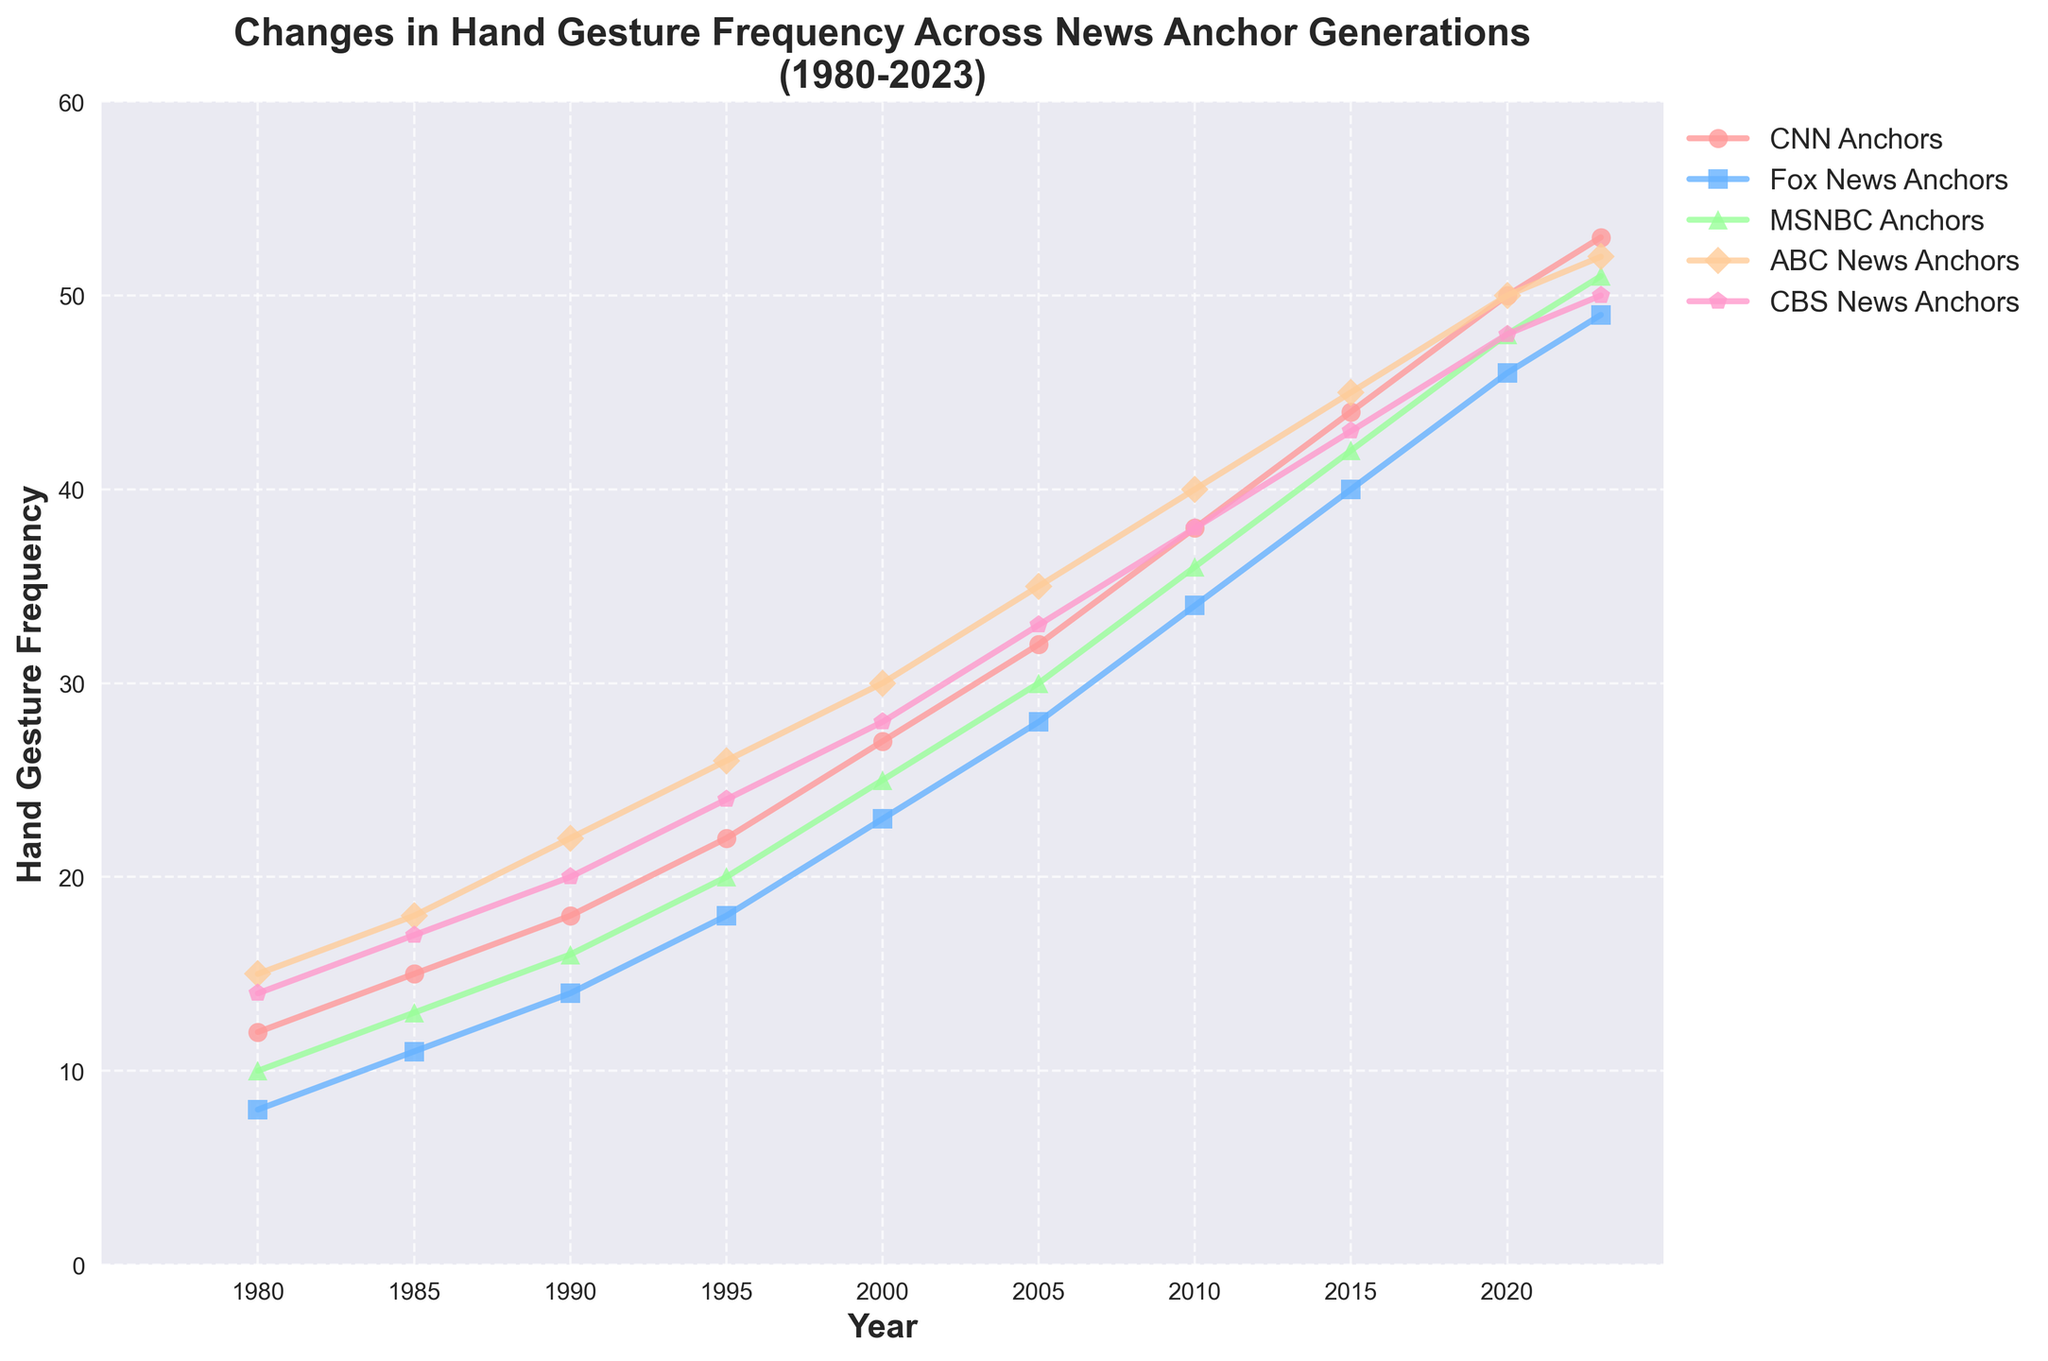What is the frequency of hand gestures for ABC News Anchors in 1995? Refer to the chart and locate the value corresponding to 1995 under ABC News Anchors which is shown as 26 hand gestures.
Answer: 26 Between which years did MSNBC Anchors show the greatest increase in hand gesture frequency? Compare the increase in frequency across intervals and find the largest increase for MSNBC Anchors. The most significant increase occurred between 2010 (36) and 2015 (42), a change of 6.
Answer: 2010 to 2015 Which news network showed the least hand gesture frequency in 1980? Compare the hand gesture frequencies for all networks in 1980. Fox News Anchors had the least frequency with 8 hand gestures.
Answer: Fox News Anchors How does the frequency of hand gestures for CBS News Anchors in 2020 compare to CNN Anchors in 1990? Refer to the values for CBS News Anchors in 2020 (48) and CNN Anchors in 1990 (18). Compare these values directly.
Answer: Higher By what amount did the frequency of hand gestures for CNN Anchors increase from 1980 to 2023? Subtract the value in 1980 (12) from the value in 2023 (53) for CNN Anchors to get the increase: 53 - 12 = 41.
Answer: 41 Which two networks had the same hand gesture frequency in 2023? Look at the values for 2023 and identify which two networks match in hand gesture frequency. Both ABC News Anchors and CBS News Anchors have a frequency of 52.
Answer: ABC News Anchors and CBS News Anchors What is the average hand gesture frequency for all networks in the year 2000? Sum all hand gesture frequencies for the year 2000: (27 + 23 + 25 + 30 + 28) = 133, then divide by the number of networks (5): 133 / 5 = 26.6
Answer: 26.6 Visually, which network used blue-colored markers to represent its hand gesture frequency trend? Refer to the colors used in the line chart. The network represented with blue-colored markers is Fox News Anchors.
Answer: Fox News Anchors 